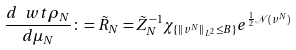Convert formula to latex. <formula><loc_0><loc_0><loc_500><loc_500>\frac { d \ w t { \rho } _ { N } } { d \mu _ { N } } \colon = \tilde { R } _ { N } = { \tilde { Z } _ { N } } ^ { - 1 } \chi _ { \{ \| v ^ { N } \| _ { L ^ { 2 } } \leq B \} } e ^ { \frac { 1 } { 2 } \mathcal { N } ( v ^ { N } ) }</formula> 